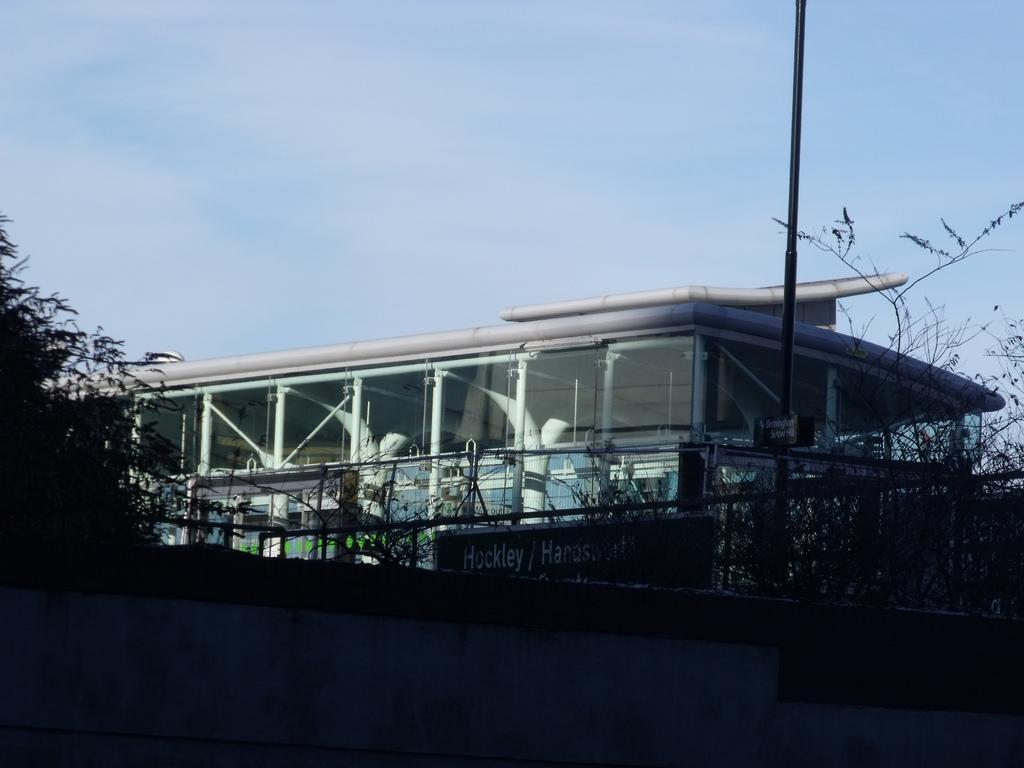How would you summarize this image in a sentence or two? In this image, we can see a building. We can see a pole. We can see some boards with text. We can see the fence. There are a few plants. We can see the sky. 